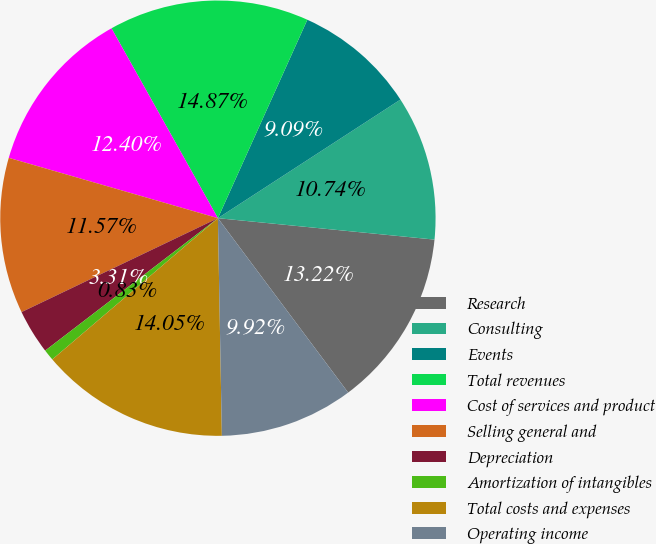<chart> <loc_0><loc_0><loc_500><loc_500><pie_chart><fcel>Research<fcel>Consulting<fcel>Events<fcel>Total revenues<fcel>Cost of services and product<fcel>Selling general and<fcel>Depreciation<fcel>Amortization of intangibles<fcel>Total costs and expenses<fcel>Operating income<nl><fcel>13.22%<fcel>10.74%<fcel>9.09%<fcel>14.87%<fcel>12.4%<fcel>11.57%<fcel>3.31%<fcel>0.83%<fcel>14.05%<fcel>9.92%<nl></chart> 